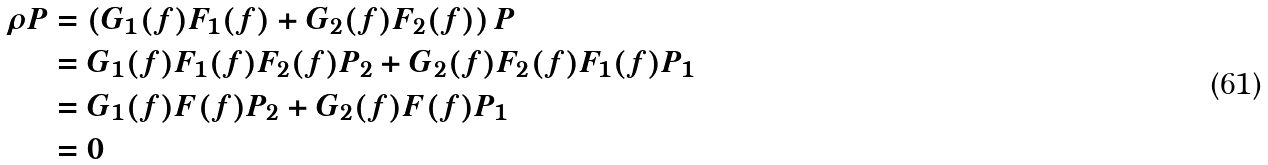Convert formula to latex. <formula><loc_0><loc_0><loc_500><loc_500>\rho P & = \left ( G _ { 1 } ( f ) F _ { 1 } ( f ) + G _ { 2 } ( f ) F _ { 2 } ( f ) \right ) P \\ & = G _ { 1 } ( f ) F _ { 1 } ( f ) F _ { 2 } ( f ) P _ { 2 } + G _ { 2 } ( f ) F _ { 2 } ( f ) F _ { 1 } ( f ) P _ { 1 } \\ & = G _ { 1 } ( f ) F ( f ) P _ { 2 } + G _ { 2 } ( f ) F ( f ) P _ { 1 } \quad \\ & = 0 \quad</formula> 